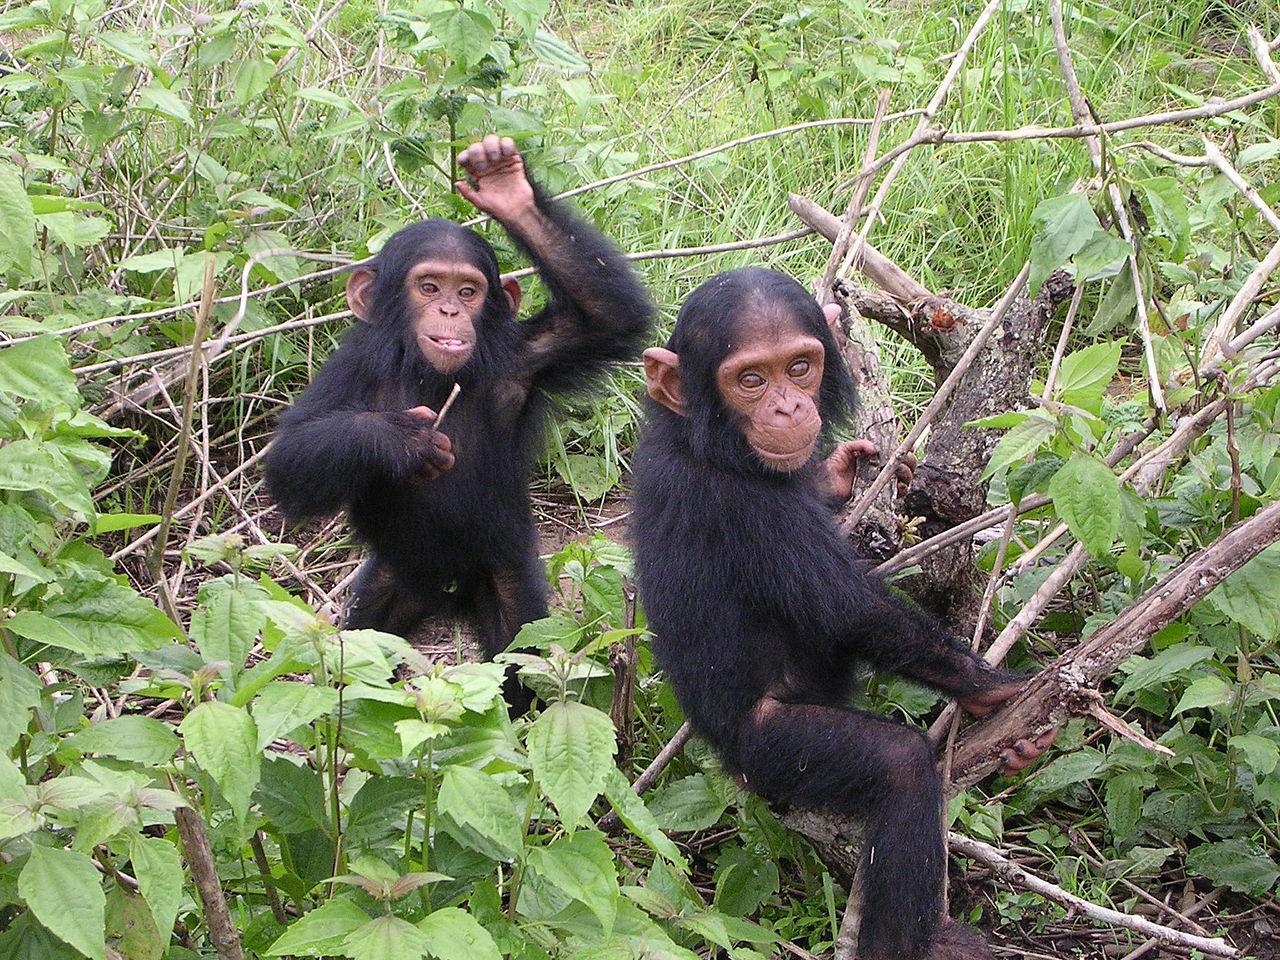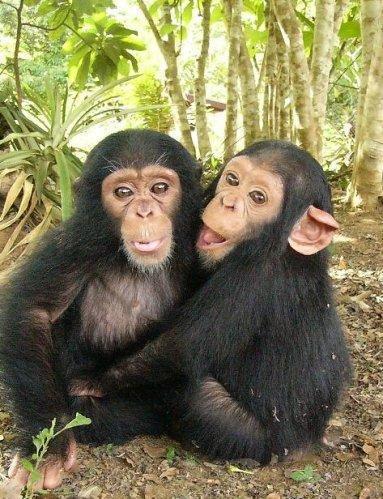The first image is the image on the left, the second image is the image on the right. Examine the images to the left and right. Is the description "There are three or fewer apes in total." accurate? Answer yes or no. No. The first image is the image on the left, the second image is the image on the right. For the images shown, is this caption "The left image contains exactly two chimpanzees." true? Answer yes or no. Yes. 